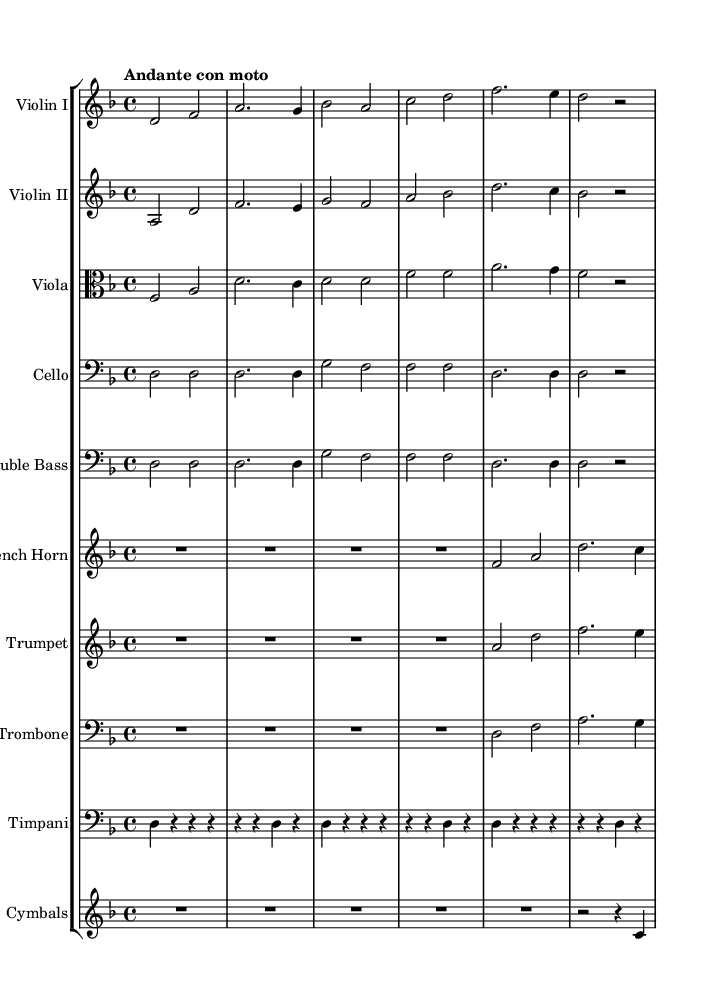What is the key signature of this music? The key signature is indicated with a flat sign before the staff lines. In this case, it shows one flat, which corresponds to the key of D minor.
Answer: D minor What is the time signature of the piece? The time signature is shown at the beginning of the staff. In this case, it is 4/4, meaning there are four beats in a measure and the quarter note gets one beat.
Answer: 4/4 What is the tempo marking of this piece? The tempo marking is written above the staff, indicating the speed of the music. Here, it says "Andante con moto," which suggests a moderately slow pace with a slight movement.
Answer: Andante con moto How many measures does the score have? To find the total number of measures, we need to count each set of bar lines in the score. Here, there are 11 measures throughout the entire score.
Answer: 11 Which instruments are featured in this score? The instruments are named at the beginning of each staff line. The score features Violin I, Violin II, Viola, Cello, Double Bass, French Horn, Trumpet, Trombone, Timpani, and Cymbals.
Answer: Violin I, Violin II, Viola, Cello, Double Bass, French Horn, Trumpet, Trombone, Timpani, Cymbals What is the role of the timpani in this piece? The timpani is usually used for dramatic emphasis and rhythmic support, which is evident here as it plays a rhythmically steady pattern, providing a foundation for the orchestral sound.
Answer: Dramatic emphasis 